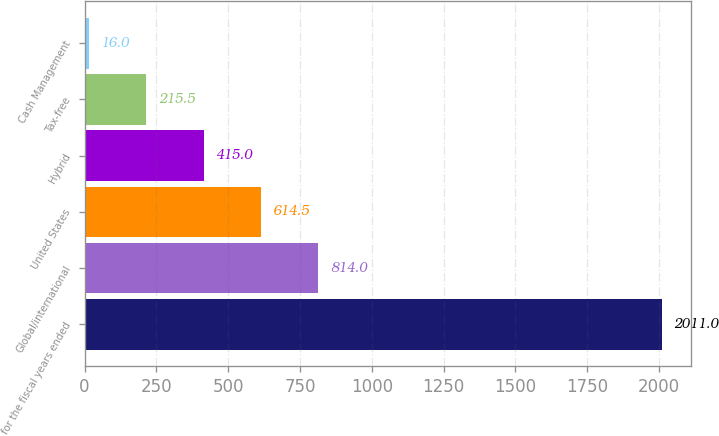Convert chart. <chart><loc_0><loc_0><loc_500><loc_500><bar_chart><fcel>for the fiscal years ended<fcel>Global/international<fcel>United States<fcel>Hybrid<fcel>Tax-free<fcel>Cash Management<nl><fcel>2011<fcel>814<fcel>614.5<fcel>415<fcel>215.5<fcel>16<nl></chart> 